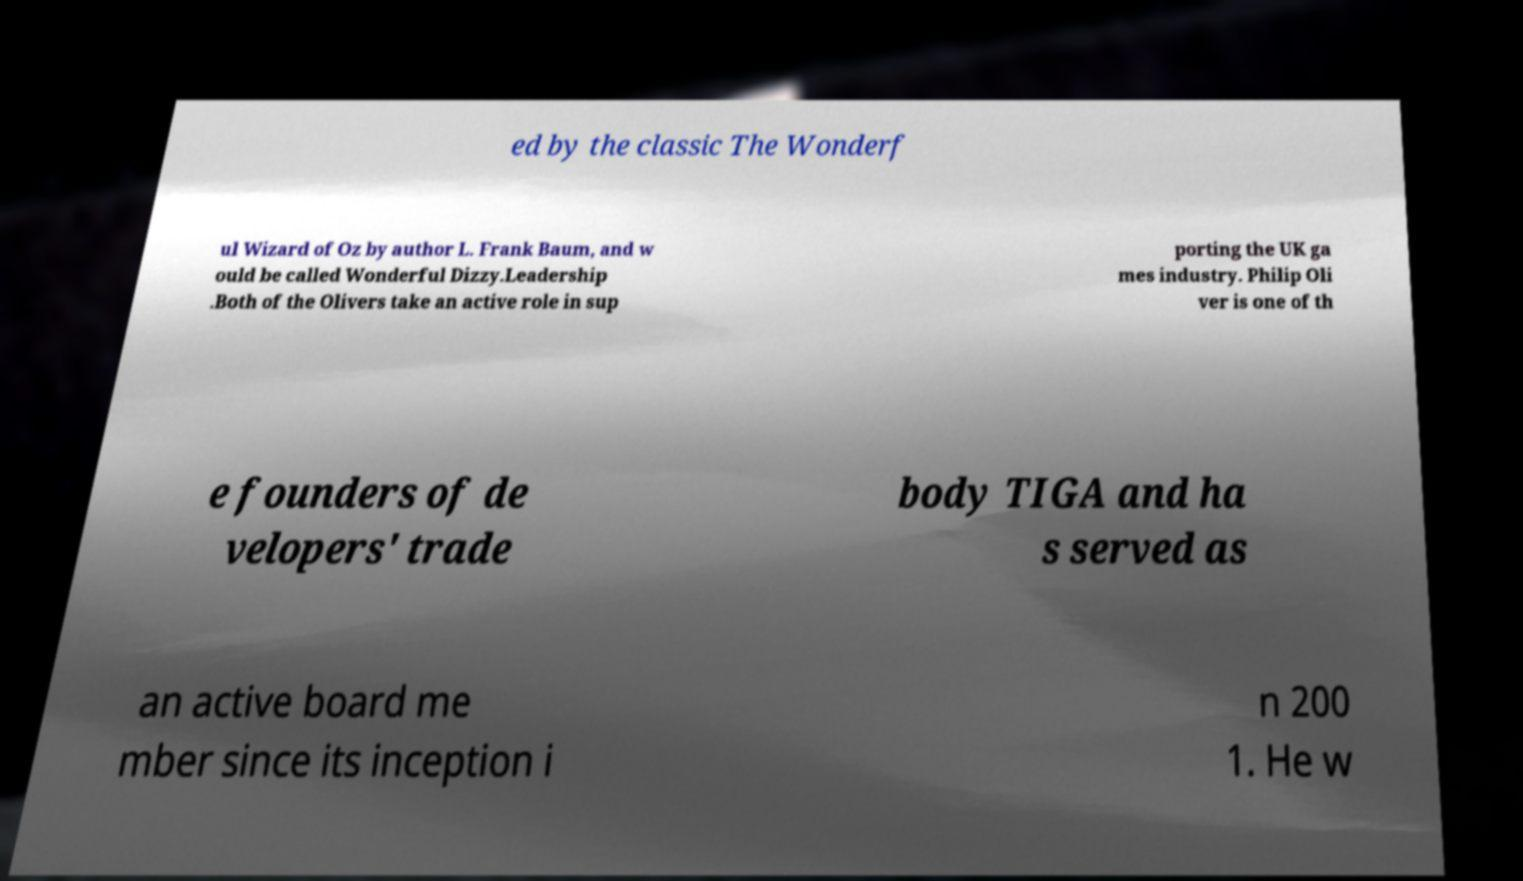Could you extract and type out the text from this image? ed by the classic The Wonderf ul Wizard of Oz by author L. Frank Baum, and w ould be called Wonderful Dizzy.Leadership .Both of the Olivers take an active role in sup porting the UK ga mes industry. Philip Oli ver is one of th e founders of de velopers' trade body TIGA and ha s served as an active board me mber since its inception i n 200 1. He w 